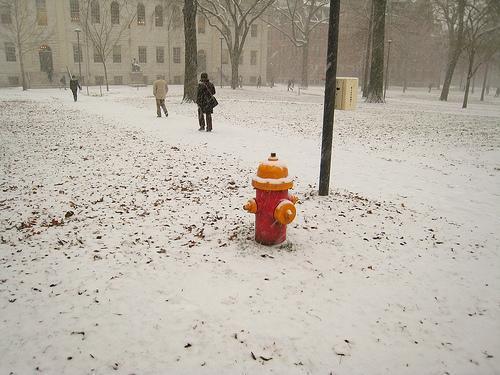How many people are wearing a white coat?
Give a very brief answer. 1. 